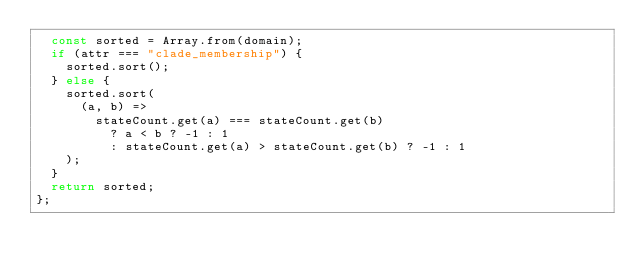<code> <loc_0><loc_0><loc_500><loc_500><_JavaScript_>  const sorted = Array.from(domain);
  if (attr === "clade_membership") {
    sorted.sort();
  } else {
    sorted.sort(
      (a, b) =>
        stateCount.get(a) === stateCount.get(b)
          ? a < b ? -1 : 1
          : stateCount.get(a) > stateCount.get(b) ? -1 : 1
    );
  }
  return sorted;
};
</code> 